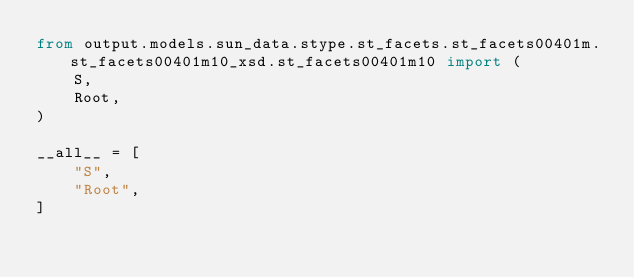<code> <loc_0><loc_0><loc_500><loc_500><_Python_>from output.models.sun_data.stype.st_facets.st_facets00401m.st_facets00401m10_xsd.st_facets00401m10 import (
    S,
    Root,
)

__all__ = [
    "S",
    "Root",
]
</code> 